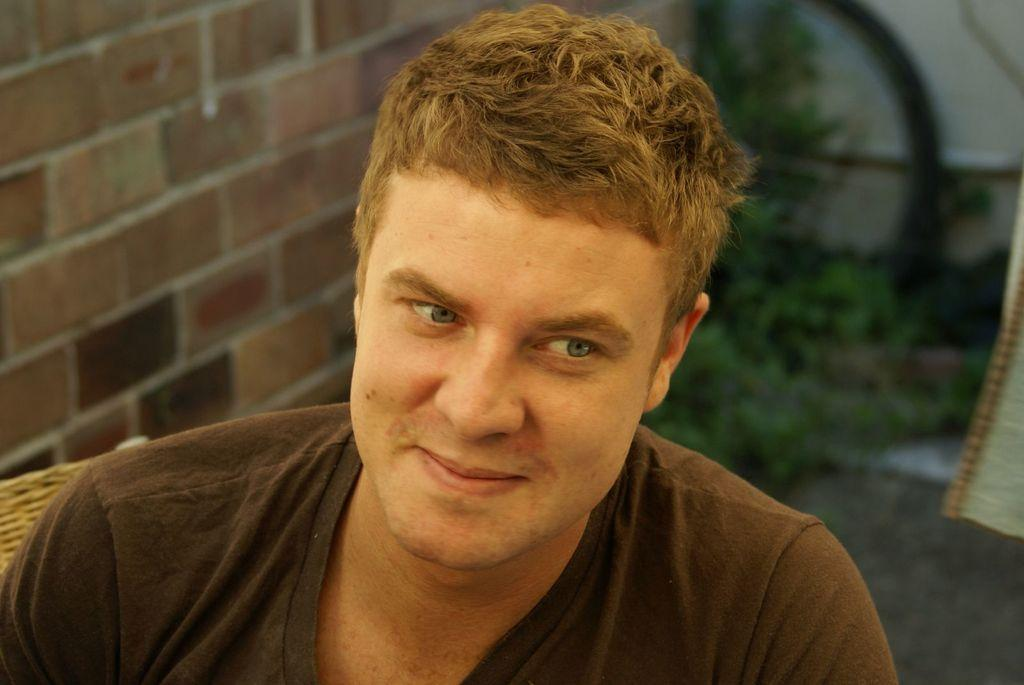Who is present in the image? There is a man in the image. What is the man's facial expression? The man is smiling. What can be seen on the left side of the image? There is a brick wall on the left side of the image. What type of vegetation is visible in the background of the image? There are plants visible in the background of the image. What type of pain is the man experiencing in the image? There is no indication in the image that the man is experiencing any pain. Can you tell me how many police officers are present in the image? There are no police officers present in the image. 